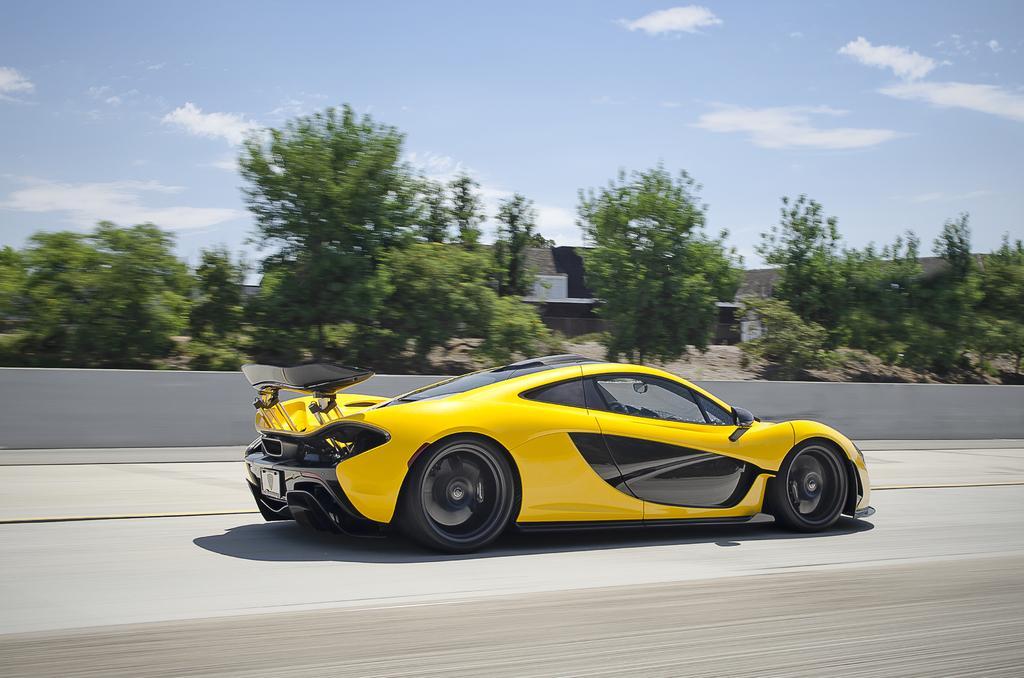Could you give a brief overview of what you see in this image? In this image in the center there is one car, and in the background there are trees wall and some objects. At the bottom there is road, and at the top there is sky. 